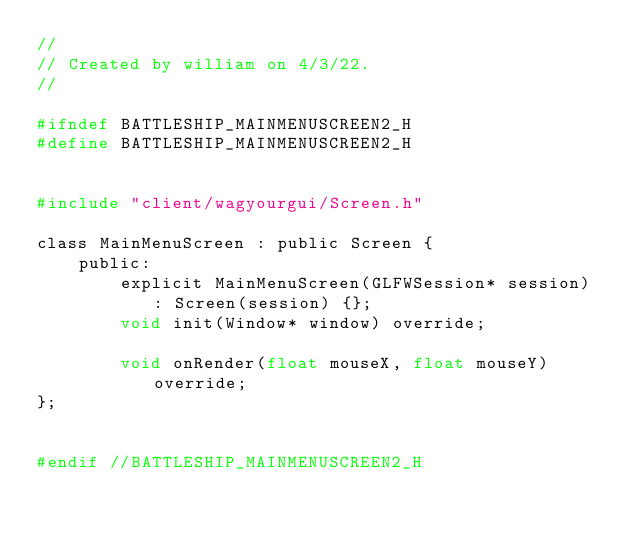<code> <loc_0><loc_0><loc_500><loc_500><_C_>//
// Created by william on 4/3/22.
//

#ifndef BATTLESHIP_MAINMENUSCREEN2_H
#define BATTLESHIP_MAINMENUSCREEN2_H


#include "client/wagyourgui/Screen.h"

class MainMenuScreen : public Screen {
    public:
        explicit MainMenuScreen(GLFWSession* session) : Screen(session) {};
        void init(Window* window) override;

        void onRender(float mouseX, float mouseY) override;
};


#endif //BATTLESHIP_MAINMENUSCREEN2_H
</code> 